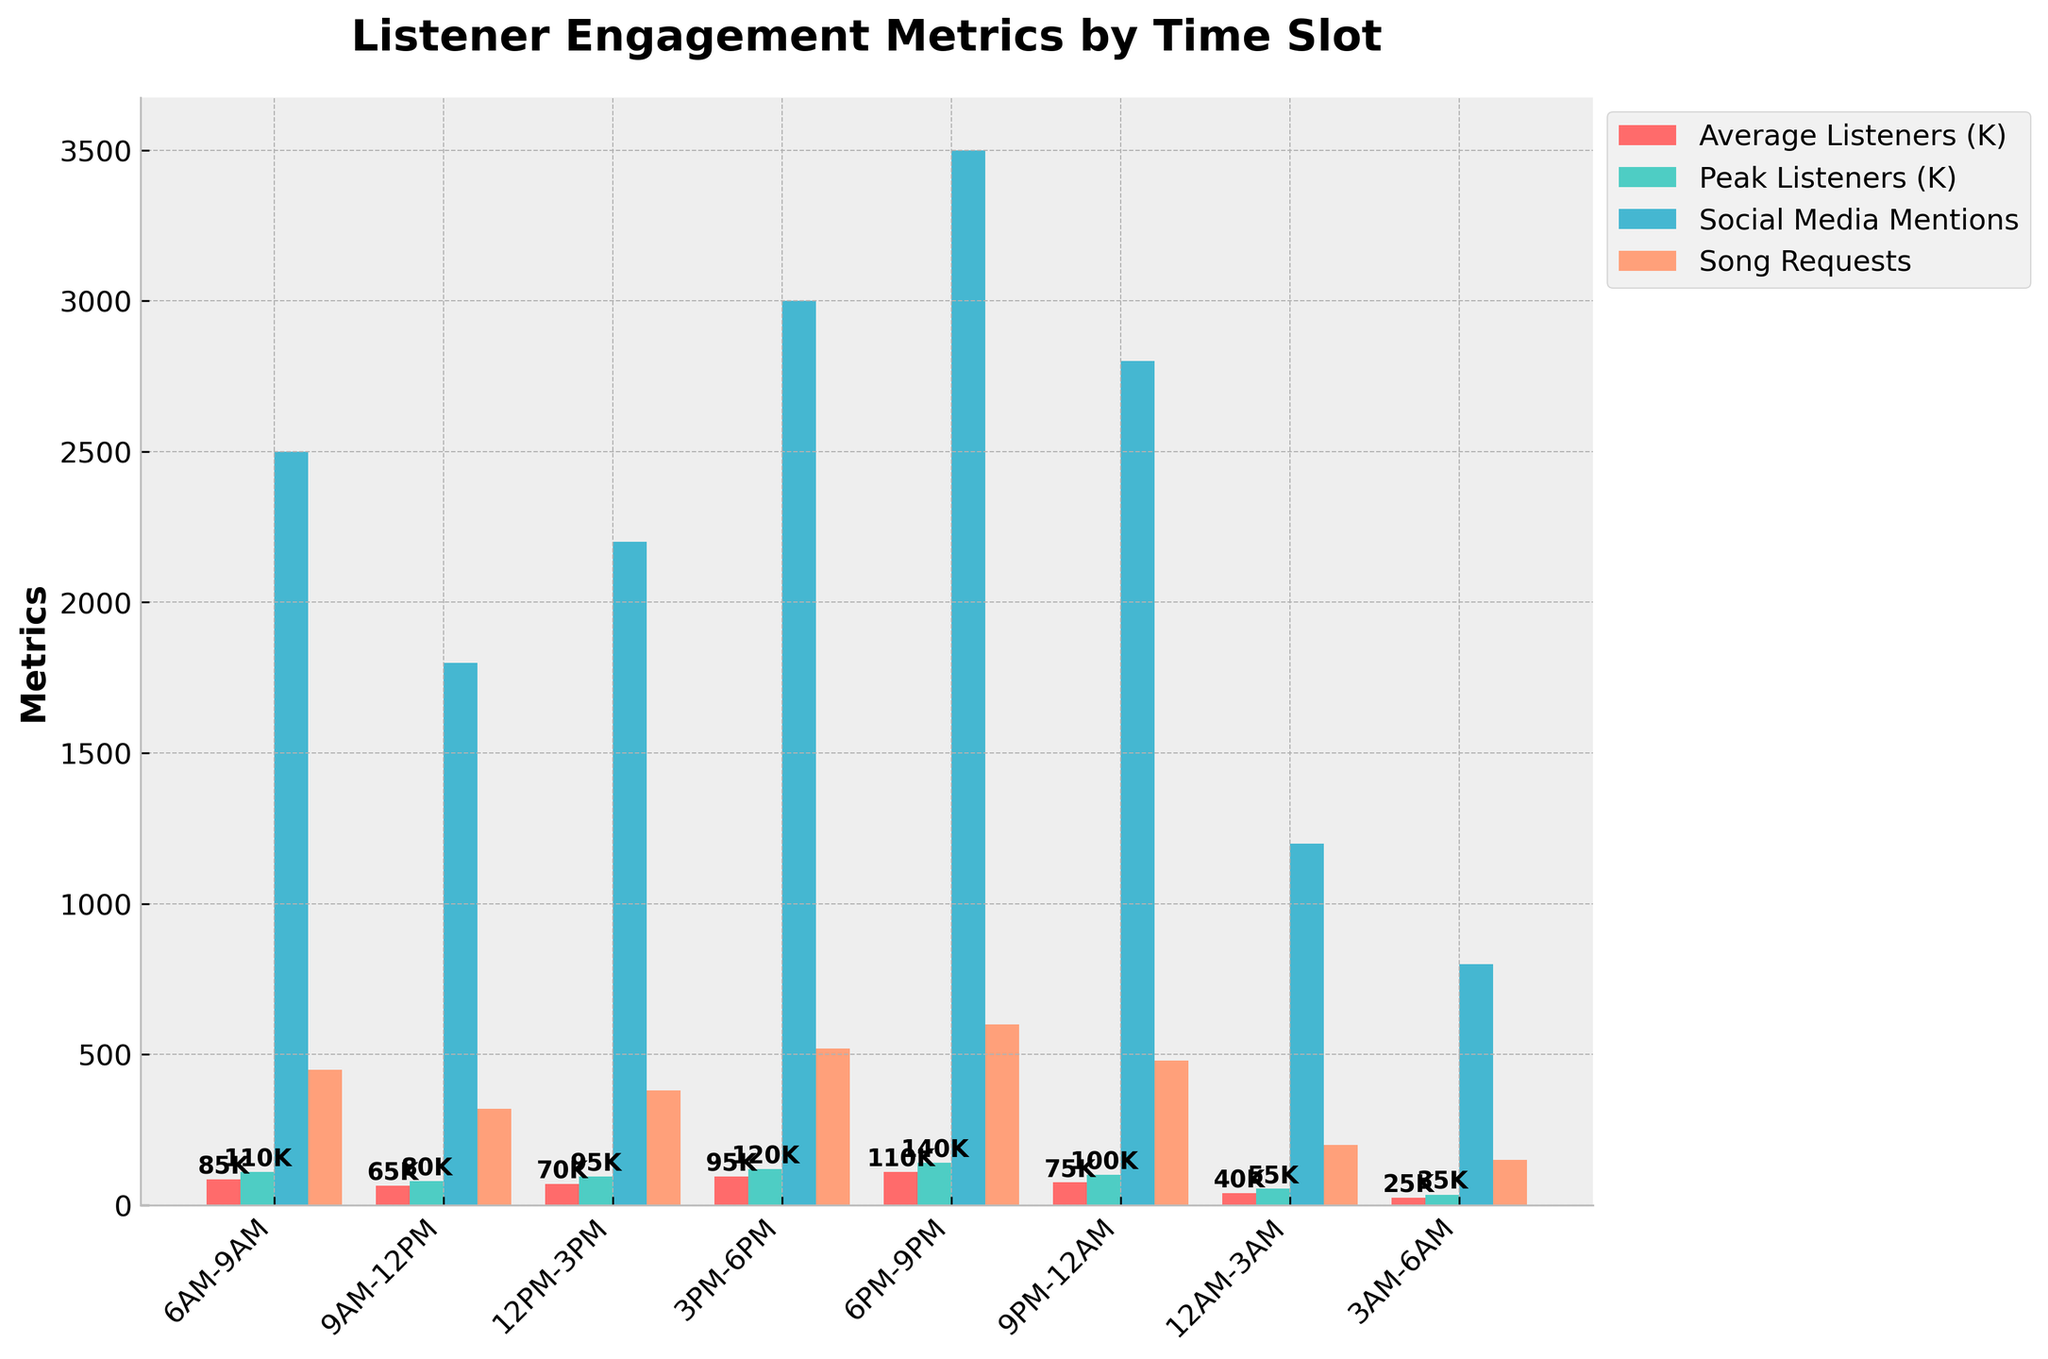What time slot has the highest number of average listeners? Look for the bar representing "Average Listeners (K)" and observe which time slot's bar is the tallest. The tallest bar is at 6PM-9PM.
Answer: 6PM-9PM Which time slot has the most song requests? Locate the bars representing "Song Requests" and find which one is the highest. The highest bar is at 6PM-9PM.
Answer: 6PM-9PM What is the difference between the peak listeners in the 3PM-6PM slot versus the 9PM-12AM slot? Identify the bars representing "Peak Listeners (K)" for both 3PM-6PM (120K) and 9PM-12AM (100K) time slots and calculate the difference: 120K - 100K.
Answer: 20K How many more average listeners are there in the 6PM-9PM time slot compared to the 9AM-12PM time slot? Check the bars for "Average Listeners (K)" in the 6PM-9PM (110K) and 9AM-12PM (65K) time slots and subtract the values: 110K - 65K.
Answer: 45K In which time slot are the social media mentions greater than the song requests? Compare the heights of bars representing "Social Media Mentions" and "Song Requests" for each time slot. For 6AM-9AM (2500 vs. 450), 12PM-3PM (2200 vs. 380), 3PM-6PM (3000 vs. 520), 9PM-12AM (2800 vs. 480), and 12AM-3AM slots (1200 vs. 200), social media mentions are greater. The other time slots do not meet this criterion.
Answer: 6AM-9AM, 12PM-3PM, 3PM-6PM, 9PM-12AM, 12AM-3AM What is the total number of social media mentions for all time slots combined? Add the values represented by the "Social Media Mentions" bars for all time slots: 2500 + 1800 + 2200 + 3000 + 3500 + 2800 + 1200 + 800.
Answer: 17800 Which time slot has the lowest peak listeners and what are those values? Find the shortest bar in the "Peak Listeners (K)" bars. The shortest bar corresponds to the 3AM-6AM time slot, with 35K peak listeners.
Answer: 3AM-6AM, 35K By how much does the average listeners count decrease from the peak in the 6PM-9PM slot? Subtract the "Average Listeners (K)" value in 6PM-9PM (110K) from the "Peak Listeners (K)" value in the same slot (140K): 140K - 110K.
Answer: 30K Which time slot sees the steepest increase in average listeners compared to the previous slot? Deduct the "Average Listeners (K)" values of consecutive time batches and see which has the most significant positive difference: Increments are 20000 (9AM-12PM to 12PM-3PM), 25000 (12PM-3PM to 3PM-6PM), and 15000 (3PM-6PM to 6PM-9PM ). The largest increase occurs between 3PM-6PM and 6PM-9PM.
Answer: 3PM-6PM to 6PM-9PM, 15000 